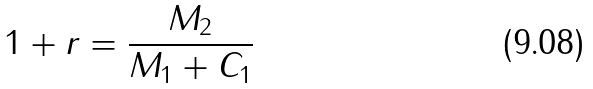<formula> <loc_0><loc_0><loc_500><loc_500>1 + r = \frac { M _ { 2 } } { M _ { 1 } + C _ { 1 } }</formula> 